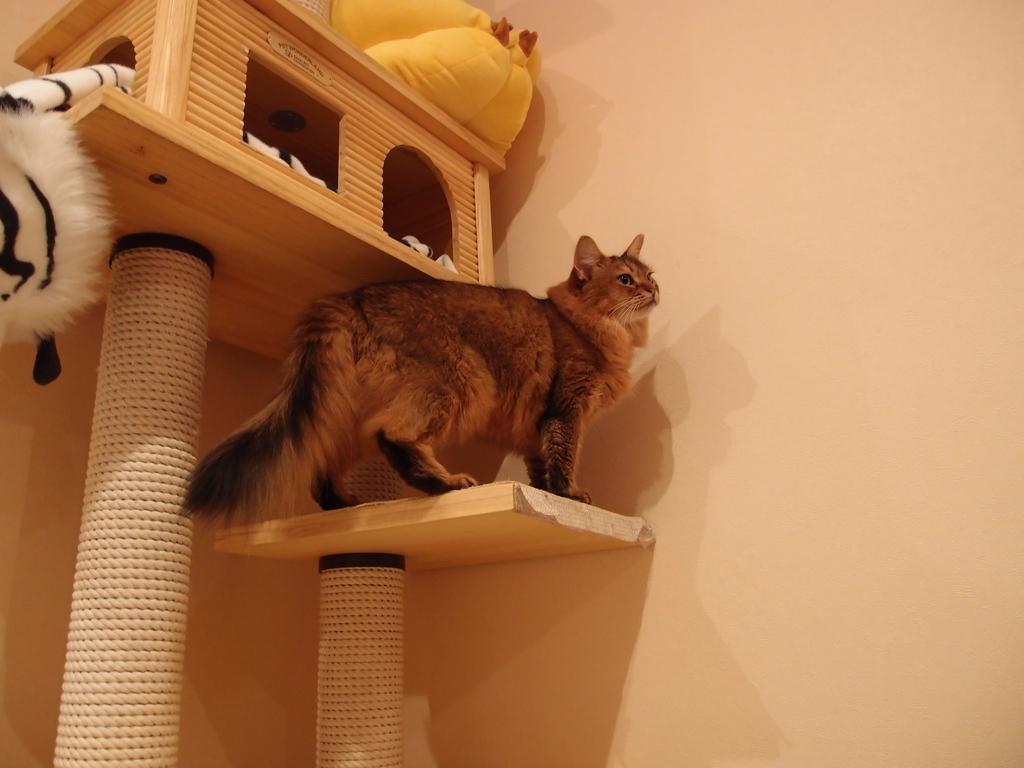What animal is standing on a strand on a pole in the image? There is a cat standing on a strand on a pole in the image. What other objects are on poles in the image? There is a toy on a small house on a pole in the image. What is inside the small house on a pole? There is another toy inside the small house in the image. What type of structure is visible in the image? There is a wall visible in the image. How many bears can be seen playing with the cat on the strand in the image? There are no bears present in the image; it features a cat standing on a strand on a pole. What type of arch is visible in the image? There is no arch visible in the image. 